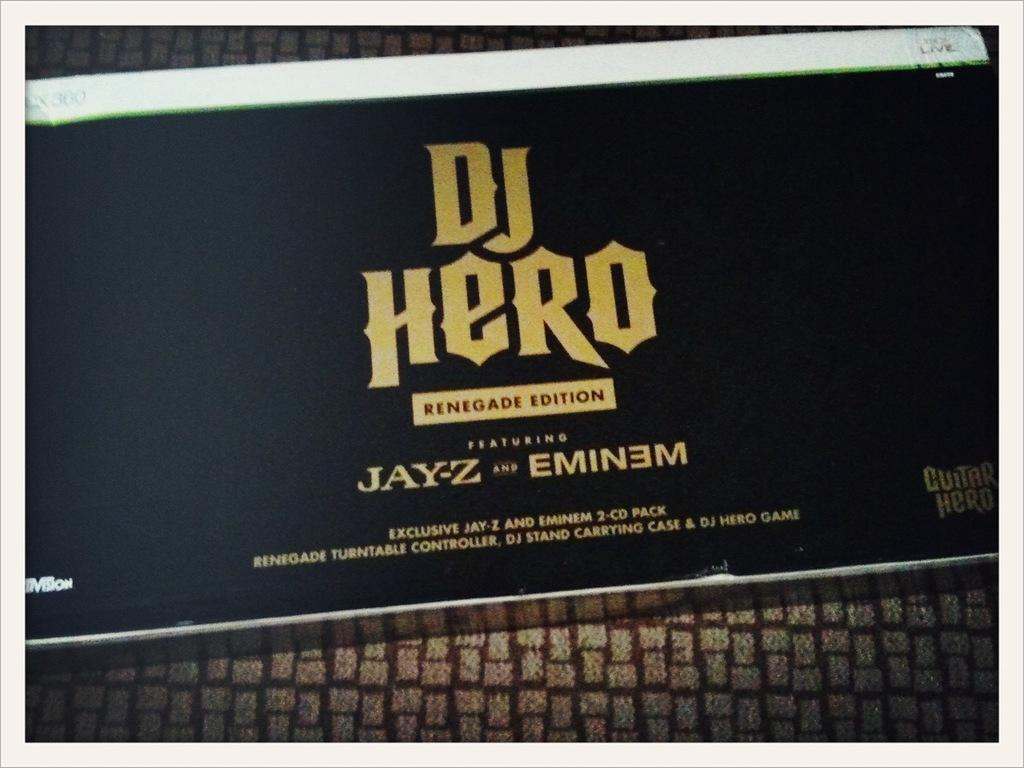<image>
Summarize the visual content of the image. Guitar Hero Dj Hero Rednegade Edition featuring Jay-z qand Eminem 